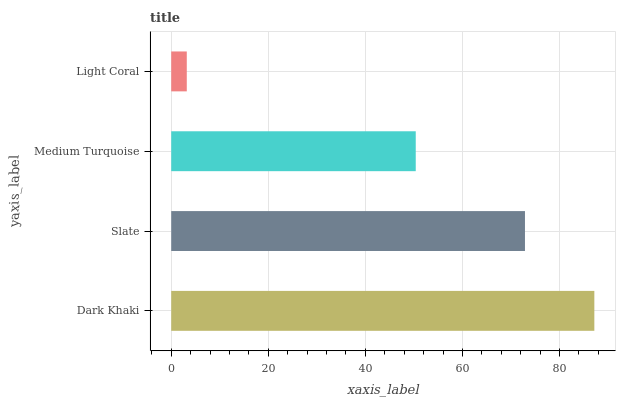Is Light Coral the minimum?
Answer yes or no. Yes. Is Dark Khaki the maximum?
Answer yes or no. Yes. Is Slate the minimum?
Answer yes or no. No. Is Slate the maximum?
Answer yes or no. No. Is Dark Khaki greater than Slate?
Answer yes or no. Yes. Is Slate less than Dark Khaki?
Answer yes or no. Yes. Is Slate greater than Dark Khaki?
Answer yes or no. No. Is Dark Khaki less than Slate?
Answer yes or no. No. Is Slate the high median?
Answer yes or no. Yes. Is Medium Turquoise the low median?
Answer yes or no. Yes. Is Medium Turquoise the high median?
Answer yes or no. No. Is Light Coral the low median?
Answer yes or no. No. 